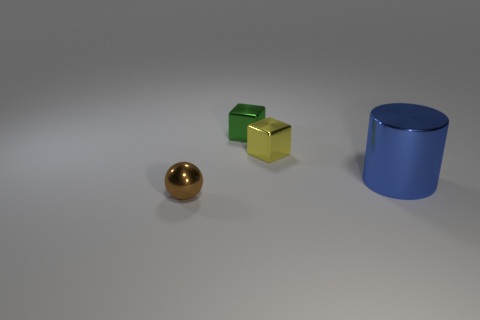There is a small green thing that is the same shape as the small yellow shiny object; what is it made of?
Ensure brevity in your answer.  Metal. Is there any other thing that has the same size as the green cube?
Your answer should be very brief. Yes. Is there a green block?
Offer a terse response. Yes. The small block that is to the left of the metal block that is in front of the tiny cube behind the small yellow cube is made of what material?
Your answer should be compact. Metal. Is the shape of the tiny brown thing the same as the small object that is behind the yellow metallic object?
Make the answer very short. No. How many big blue things have the same shape as the yellow shiny thing?
Offer a very short reply. 0. What shape is the yellow metallic object?
Give a very brief answer. Cube. How big is the thing that is in front of the shiny object that is right of the yellow metal cube?
Your answer should be very brief. Small. What number of things are either blue balls or tiny things?
Your answer should be compact. 3. Does the tiny yellow metallic thing have the same shape as the big shiny thing?
Your answer should be compact. No. 